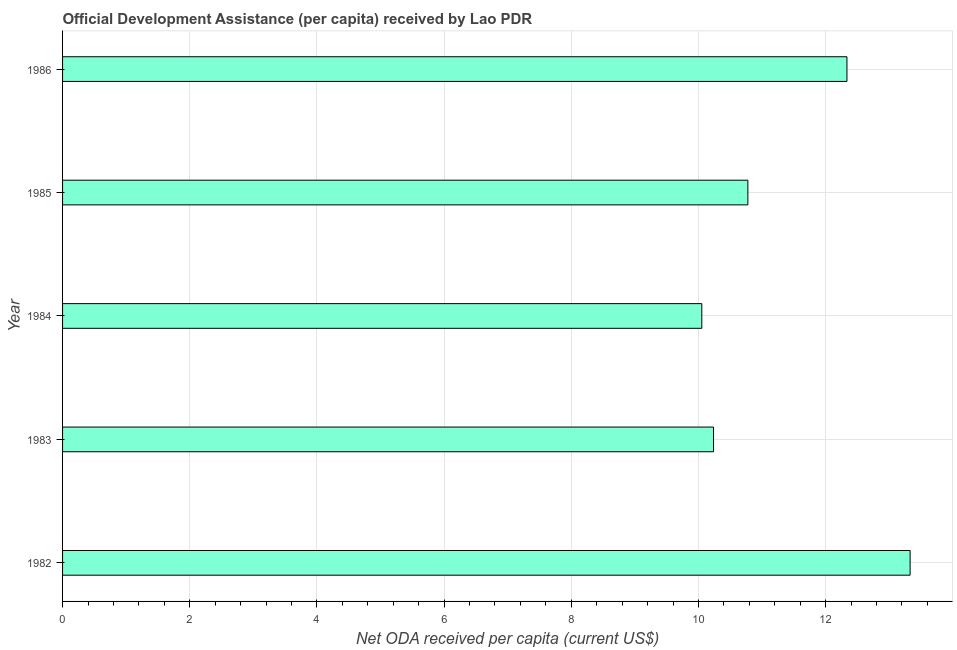Does the graph contain any zero values?
Your answer should be very brief. No. Does the graph contain grids?
Give a very brief answer. Yes. What is the title of the graph?
Your answer should be compact. Official Development Assistance (per capita) received by Lao PDR. What is the label or title of the X-axis?
Your answer should be very brief. Net ODA received per capita (current US$). What is the net oda received per capita in 1984?
Provide a succinct answer. 10.05. Across all years, what is the maximum net oda received per capita?
Your response must be concise. 13.33. Across all years, what is the minimum net oda received per capita?
Ensure brevity in your answer.  10.05. In which year was the net oda received per capita maximum?
Your response must be concise. 1982. In which year was the net oda received per capita minimum?
Keep it short and to the point. 1984. What is the sum of the net oda received per capita?
Give a very brief answer. 56.73. What is the difference between the net oda received per capita in 1983 and 1986?
Offer a terse response. -2.1. What is the average net oda received per capita per year?
Give a very brief answer. 11.35. What is the median net oda received per capita?
Offer a very short reply. 10.78. Do a majority of the years between 1986 and 1983 (inclusive) have net oda received per capita greater than 4.8 US$?
Your answer should be compact. Yes. What is the ratio of the net oda received per capita in 1983 to that in 1985?
Give a very brief answer. 0.95. Is the net oda received per capita in 1985 less than that in 1986?
Your answer should be very brief. Yes. What is the difference between the highest and the second highest net oda received per capita?
Ensure brevity in your answer.  0.99. Is the sum of the net oda received per capita in 1984 and 1985 greater than the maximum net oda received per capita across all years?
Make the answer very short. Yes. What is the difference between the highest and the lowest net oda received per capita?
Offer a terse response. 3.28. In how many years, is the net oda received per capita greater than the average net oda received per capita taken over all years?
Give a very brief answer. 2. What is the difference between two consecutive major ticks on the X-axis?
Keep it short and to the point. 2. What is the Net ODA received per capita (current US$) of 1982?
Give a very brief answer. 13.33. What is the Net ODA received per capita (current US$) of 1983?
Your response must be concise. 10.24. What is the Net ODA received per capita (current US$) of 1984?
Provide a short and direct response. 10.05. What is the Net ODA received per capita (current US$) of 1985?
Your answer should be compact. 10.78. What is the Net ODA received per capita (current US$) in 1986?
Give a very brief answer. 12.33. What is the difference between the Net ODA received per capita (current US$) in 1982 and 1983?
Keep it short and to the point. 3.09. What is the difference between the Net ODA received per capita (current US$) in 1982 and 1984?
Provide a short and direct response. 3.28. What is the difference between the Net ODA received per capita (current US$) in 1982 and 1985?
Your answer should be very brief. 2.55. What is the difference between the Net ODA received per capita (current US$) in 1983 and 1984?
Your answer should be very brief. 0.18. What is the difference between the Net ODA received per capita (current US$) in 1983 and 1985?
Offer a terse response. -0.54. What is the difference between the Net ODA received per capita (current US$) in 1983 and 1986?
Make the answer very short. -2.1. What is the difference between the Net ODA received per capita (current US$) in 1984 and 1985?
Keep it short and to the point. -0.72. What is the difference between the Net ODA received per capita (current US$) in 1984 and 1986?
Offer a very short reply. -2.28. What is the difference between the Net ODA received per capita (current US$) in 1985 and 1986?
Offer a terse response. -1.56. What is the ratio of the Net ODA received per capita (current US$) in 1982 to that in 1983?
Your response must be concise. 1.3. What is the ratio of the Net ODA received per capita (current US$) in 1982 to that in 1984?
Offer a very short reply. 1.33. What is the ratio of the Net ODA received per capita (current US$) in 1982 to that in 1985?
Keep it short and to the point. 1.24. What is the ratio of the Net ODA received per capita (current US$) in 1982 to that in 1986?
Your response must be concise. 1.08. What is the ratio of the Net ODA received per capita (current US$) in 1983 to that in 1984?
Give a very brief answer. 1.02. What is the ratio of the Net ODA received per capita (current US$) in 1983 to that in 1985?
Provide a succinct answer. 0.95. What is the ratio of the Net ODA received per capita (current US$) in 1983 to that in 1986?
Provide a succinct answer. 0.83. What is the ratio of the Net ODA received per capita (current US$) in 1984 to that in 1985?
Offer a very short reply. 0.93. What is the ratio of the Net ODA received per capita (current US$) in 1984 to that in 1986?
Provide a short and direct response. 0.81. What is the ratio of the Net ODA received per capita (current US$) in 1985 to that in 1986?
Provide a succinct answer. 0.87. 